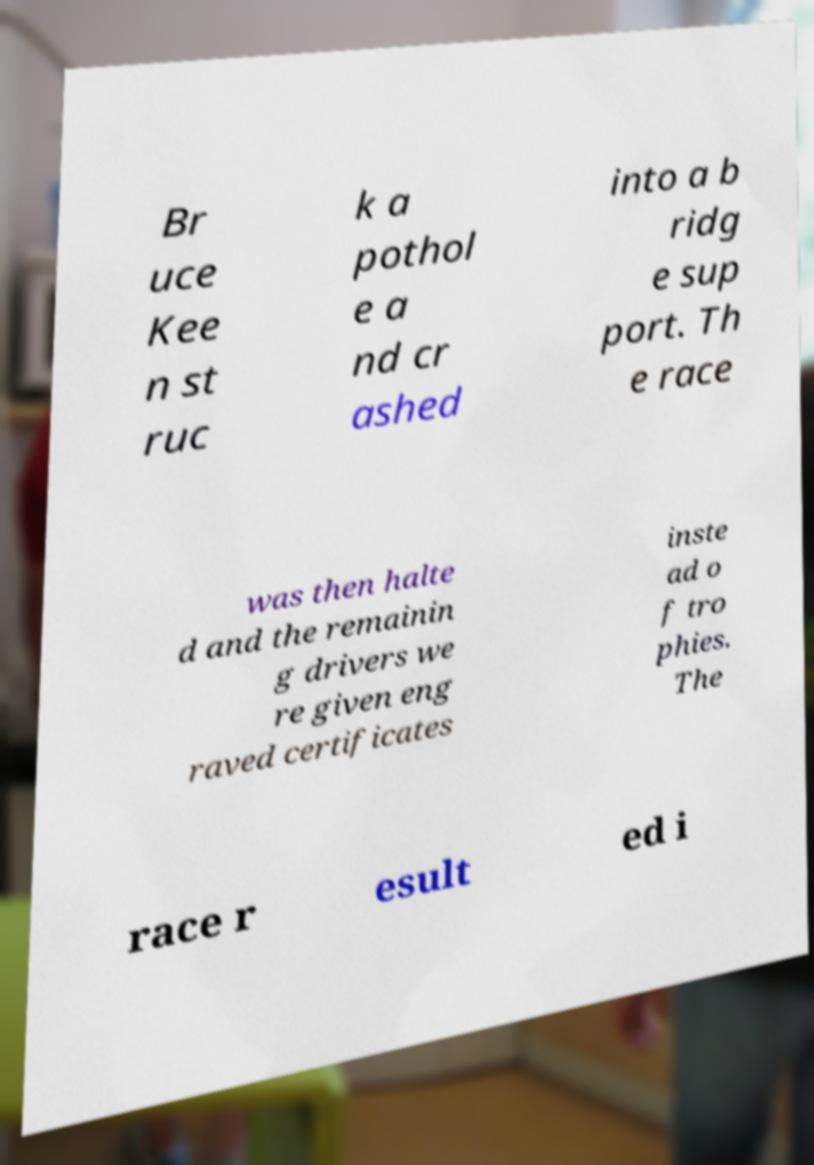Please identify and transcribe the text found in this image. Br uce Kee n st ruc k a pothol e a nd cr ashed into a b ridg e sup port. Th e race was then halte d and the remainin g drivers we re given eng raved certificates inste ad o f tro phies. The race r esult ed i 